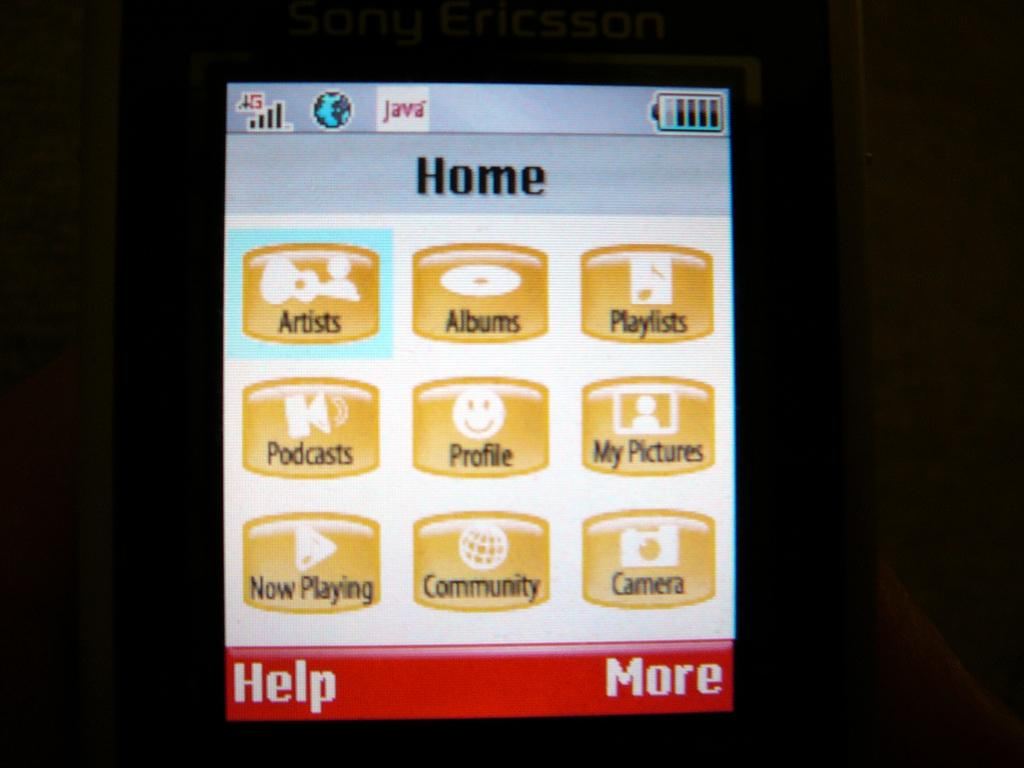<image>
Describe the image concisely. A phone home page includes many selections, including one for podcasts. 